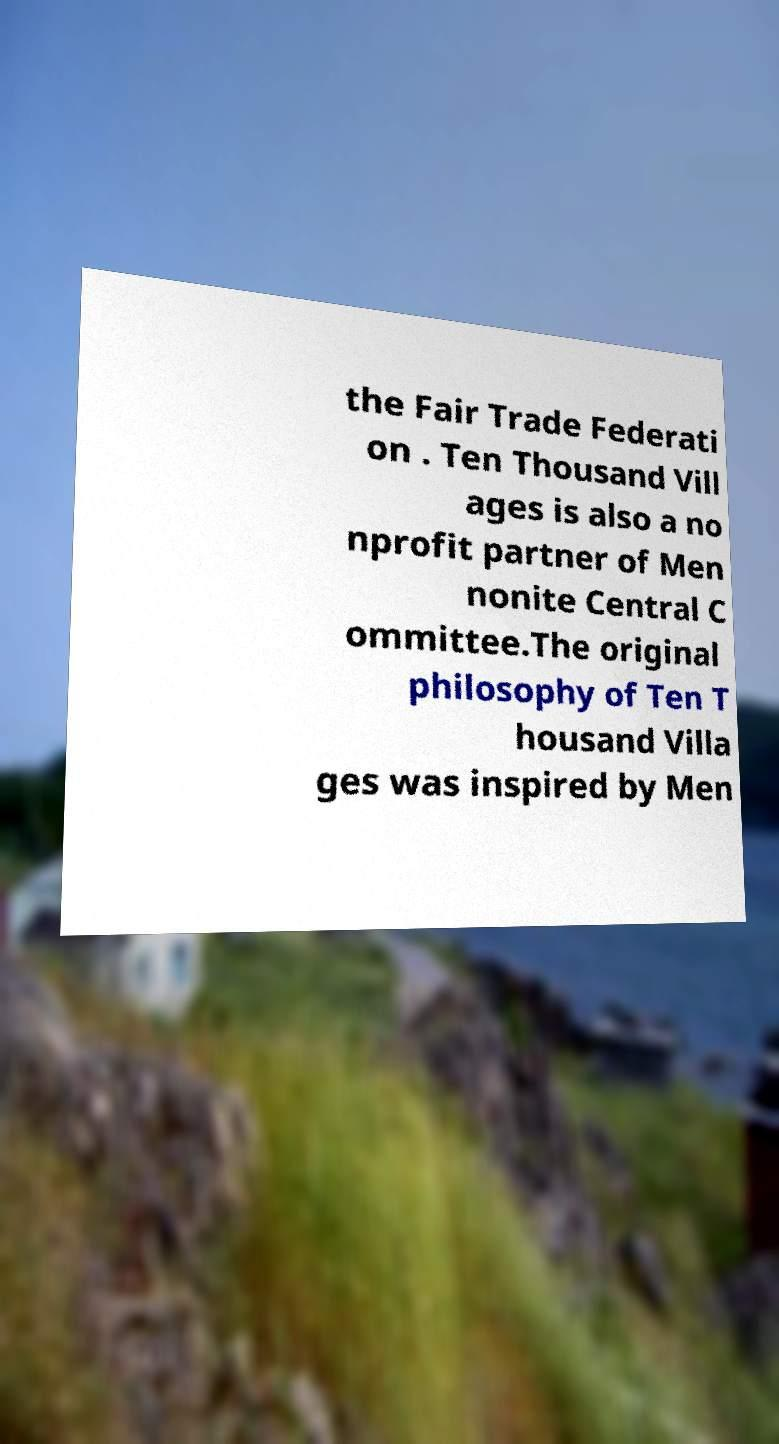Please identify and transcribe the text found in this image. the Fair Trade Federati on . Ten Thousand Vill ages is also a no nprofit partner of Men nonite Central C ommittee.The original philosophy of Ten T housand Villa ges was inspired by Men 